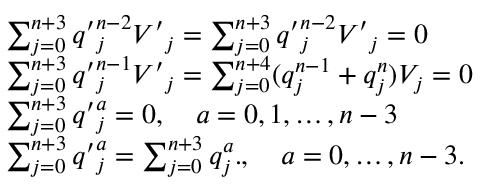Convert formula to latex. <formula><loc_0><loc_0><loc_500><loc_500>\begin{array} { l c r } { { \sum _ { j = 0 } ^ { n + 3 } { q ^ { \prime } } _ { j } ^ { n - 2 } { V ^ { \prime } } _ { j } = \sum _ { j = 0 } ^ { n + 3 } { q ^ { \prime } } _ { j } ^ { n - 2 } { V ^ { \prime } } _ { j } = 0 } } \\ { { \sum _ { j = 0 } ^ { n + 3 } { q ^ { \prime } } _ { j } ^ { n - 1 } { V ^ { \prime } } _ { j } = \sum _ { j = 0 } ^ { n + 4 } ( q _ { j } ^ { n - 1 } + q _ { j } ^ { n } ) V _ { j } = 0 } } \\ { { \sum _ { j = 0 } ^ { n + 3 } { q ^ { \prime } } _ { j } ^ { a } = 0 , \quad a = 0 , 1 , \dots , n - 3 } } \\ { { \sum _ { j = 0 } ^ { n + 3 } { q ^ { \prime } } _ { j } ^ { a } = \sum _ { j = 0 } ^ { n + 3 } q _ { j } ^ { a } . , \quad a = 0 , \dots , n - 3 . } } \end{array}</formula> 